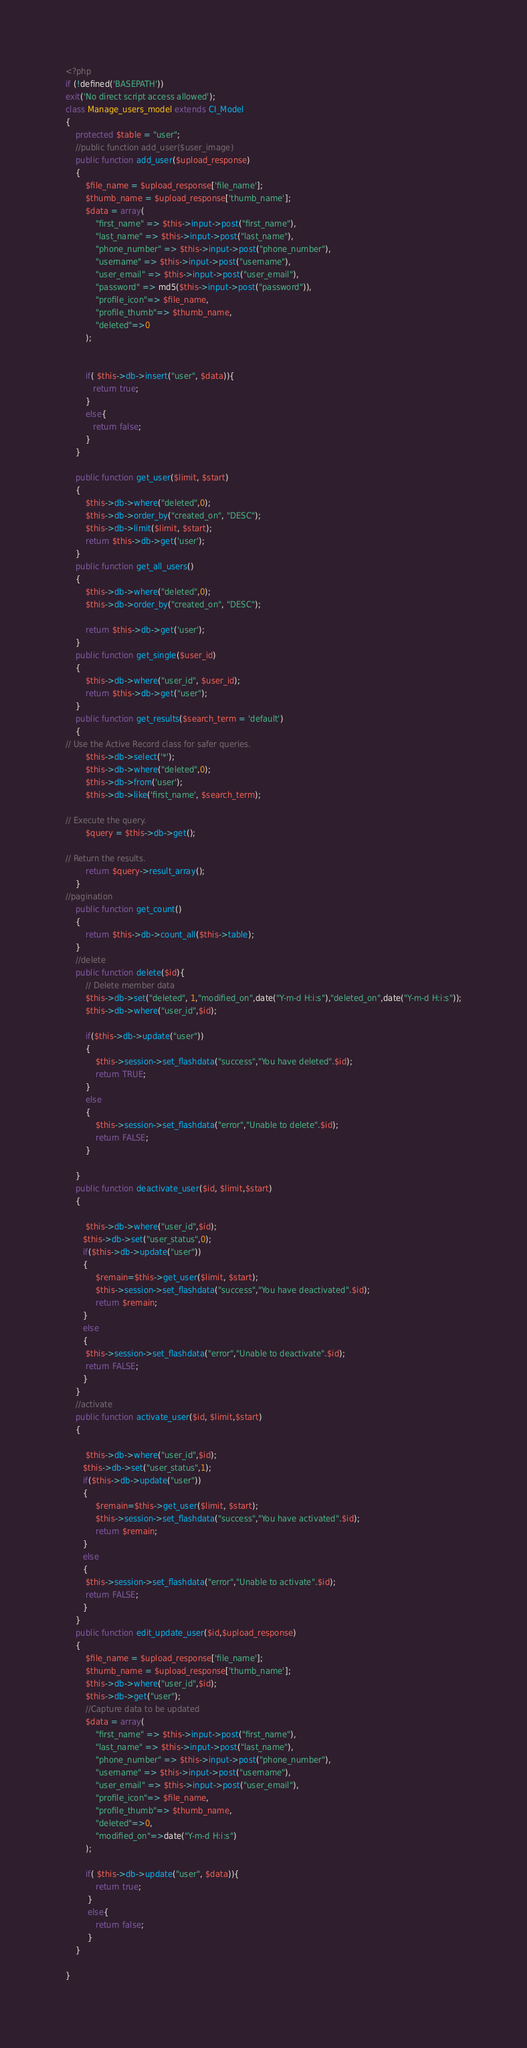<code> <loc_0><loc_0><loc_500><loc_500><_PHP_><?php
if (!defined('BASEPATH')) 
exit('No direct script access allowed'); 
class Manage_users_model extends CI_Model
{
    protected $table = "user";
    //public function add_user($user_image)
    public function add_user($upload_response)
    {
        $file_name = $upload_response['file_name'];
        $thumb_name = $upload_response['thumb_name'];
        $data = array(
            "first_name" => $this->input->post("first_name"),
            "last_name" => $this->input->post("last_name"),
            "phone_number" => $this->input->post("phone_number"),
            "username" => $this->input->post("username"),
            "user_email" => $this->input->post("user_email"),
            "password" => md5($this->input->post("password")),
            "profile_icon"=> $file_name,
            "profile_thumb"=> $thumb_name,
            "deleted"=>0
        );

        
        if( $this->db->insert("user", $data)){
           return true;
        }
        else{
           return false;
        }
    }
   
    public function get_user($limit, $start)
    {
        $this->db->where("deleted",0);
        $this->db->order_by("created_on", "DESC");
        $this->db->limit($limit, $start);
        return $this->db->get('user');
    }
    public function get_all_users()
    {
        $this->db->where("deleted",0);
        $this->db->order_by("created_on", "DESC");

        return $this->db->get('user');
    }
    public function get_single($user_id)
    {
        $this->db->where("user_id", $user_id);
        return $this->db->get("user");
    }
    public function get_results($search_term = 'default')
    {
// Use the Active Record class for safer queries.
        $this->db->select('*');
        $this->db->where("deleted",0);
        $this->db->from('user');
        $this->db->like('first_name', $search_term);

// Execute the query.
        $query = $this->db->get();

// Return the results.
        return $query->result_array();
    }
//pagination
    public function get_count()
    {
        return $this->db->count_all($this->table);
    }
    //delete
    public function delete($id){
        // Delete member data
        $this->db->set("deleted", 1,"modified_on",date("Y-m-d H:i:s"),"deleted_on",date("Y-m-d H:i:s"));
        $this->db->where("user_id",$id);
       
        if($this->db->update("user"))
        {
            $this->session->set_flashdata("success","You have deleted".$id);
            return TRUE;
        }
        else
        {
            $this->session->set_flashdata("error","Unable to delete".$id);
            return FALSE;
        }
        
    }
    public function deactivate_user($id, $limit,$start)
    {
        
        $this->db->where("user_id",$id);
       $this->db->set("user_status",0);
       if($this->db->update("user"))
       {
            $remain=$this->get_user($limit, $start);
            $this->session->set_flashdata("success","You have deactivated".$id);
            return $remain;
       }
       else 
       {
        $this->session->set_flashdata("error","Unable to deactivate".$id);
        return FALSE;
       }
    }
    //activate
    public function activate_user($id, $limit,$start)
    {
        
        $this->db->where("user_id",$id);
       $this->db->set("user_status",1);
       if($this->db->update("user"))
       {
            $remain=$this->get_user($limit, $start);
            $this->session->set_flashdata("success","You have activated".$id);
            return $remain;
       }
       else 
       {
        $this->session->set_flashdata("error","Unable to activate".$id);
        return FALSE;
       }
    }
    public function edit_update_user($id,$upload_response)
    {
        $file_name = $upload_response['file_name'];
        $thumb_name = $upload_response['thumb_name'];
        $this->db->where("user_id",$id);
        $this->db->get("user");
        //Capture data to be updated
        $data = array(
            "first_name" => $this->input->post("first_name"),
            "last_name" => $this->input->post("last_name"),
            "phone_number" => $this->input->post("phone_number"),
            "username" => $this->input->post("username"),
            "user_email" => $this->input->post("user_email"),
            "profile_icon"=> $file_name,
            "profile_thumb"=> $thumb_name,
            "deleted"=>0,
            "modified_on"=>date("Y-m-d H:i:s")
        );
         
        if( $this->db->update("user", $data)){
            return true;
         }
         else{
            return false;
         }
    }

}
</code> 